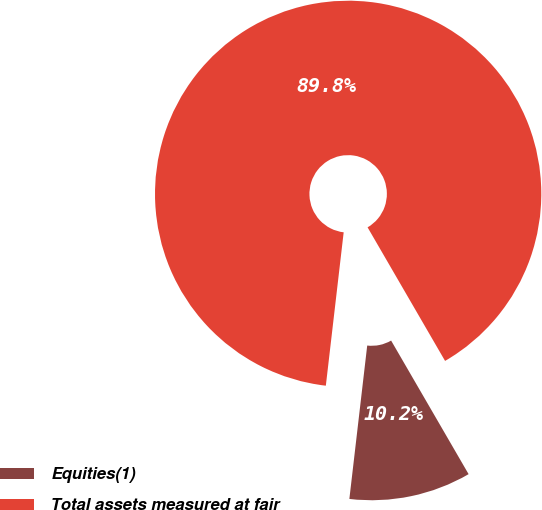Convert chart to OTSL. <chart><loc_0><loc_0><loc_500><loc_500><pie_chart><fcel>Equities(1)<fcel>Total assets measured at fair<nl><fcel>10.21%<fcel>89.79%<nl></chart> 